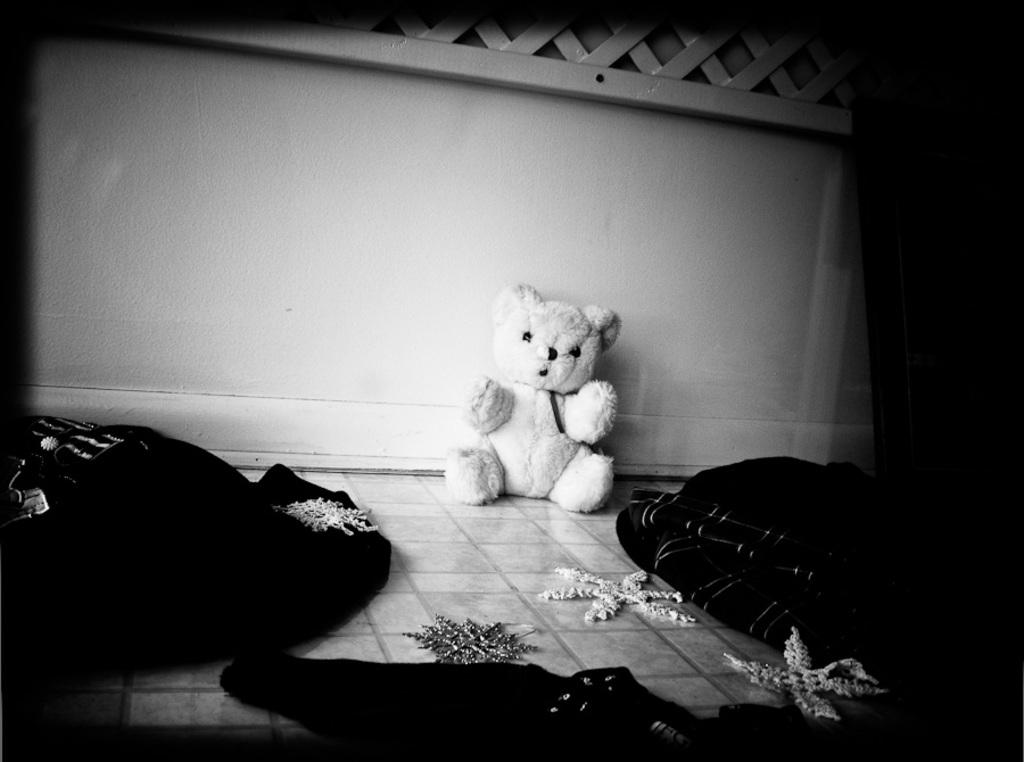What type of toy is present in the image? There is a teddy bear in the image. What else can be seen at the bottom of the image? There are clothes at the bottom of the image. What is visible in the background of the image? There is a wall in the background of the image. What type of bead is used to decorate the teddy bear in the image? There is no bead present on the teddy bear in the image. What type of meat is being prepared in the image? There is no meat or any indication of food preparation in the image. 